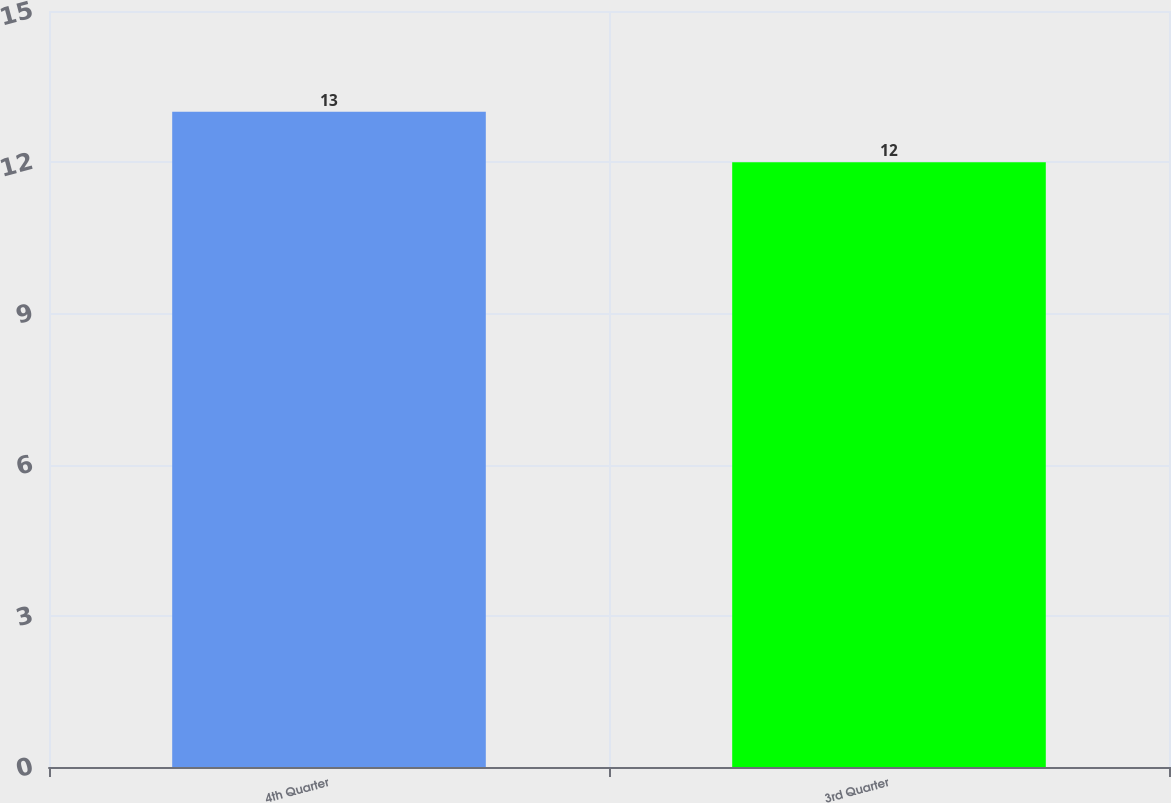<chart> <loc_0><loc_0><loc_500><loc_500><bar_chart><fcel>4th Quarter<fcel>3rd Quarter<nl><fcel>13<fcel>12<nl></chart> 